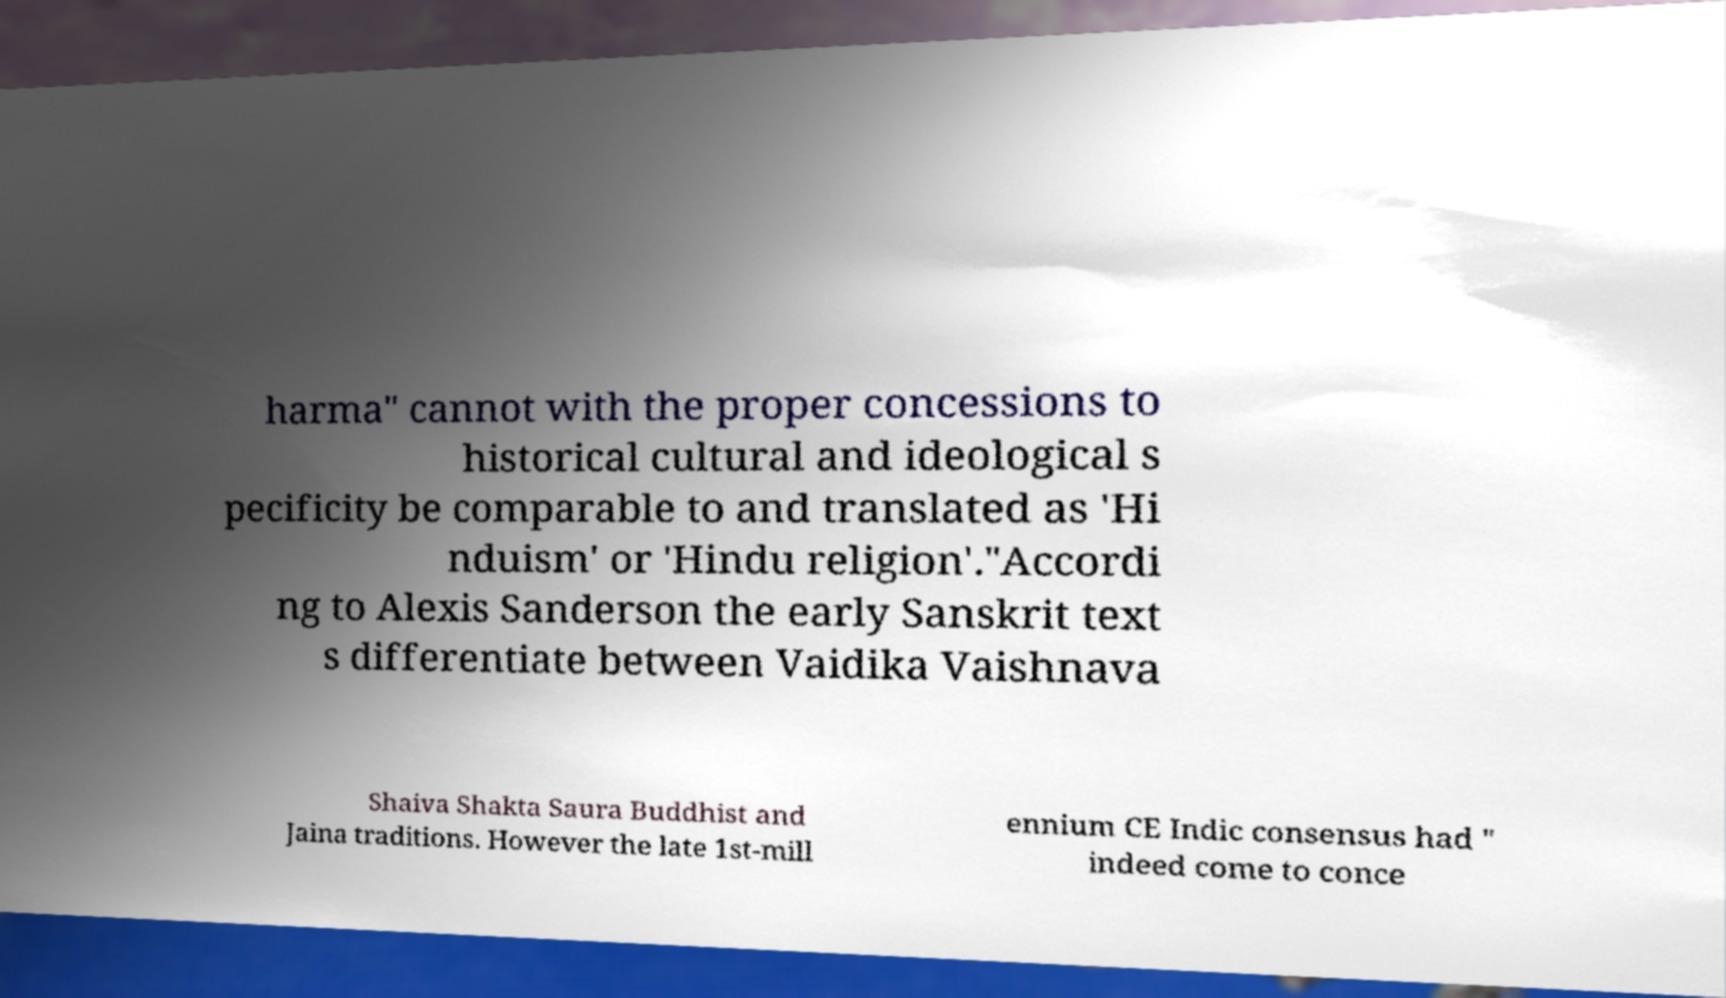Can you accurately transcribe the text from the provided image for me? harma" cannot with the proper concessions to historical cultural and ideological s pecificity be comparable to and translated as 'Hi nduism' or 'Hindu religion'."Accordi ng to Alexis Sanderson the early Sanskrit text s differentiate between Vaidika Vaishnava Shaiva Shakta Saura Buddhist and Jaina traditions. However the late 1st-mill ennium CE Indic consensus had " indeed come to conce 